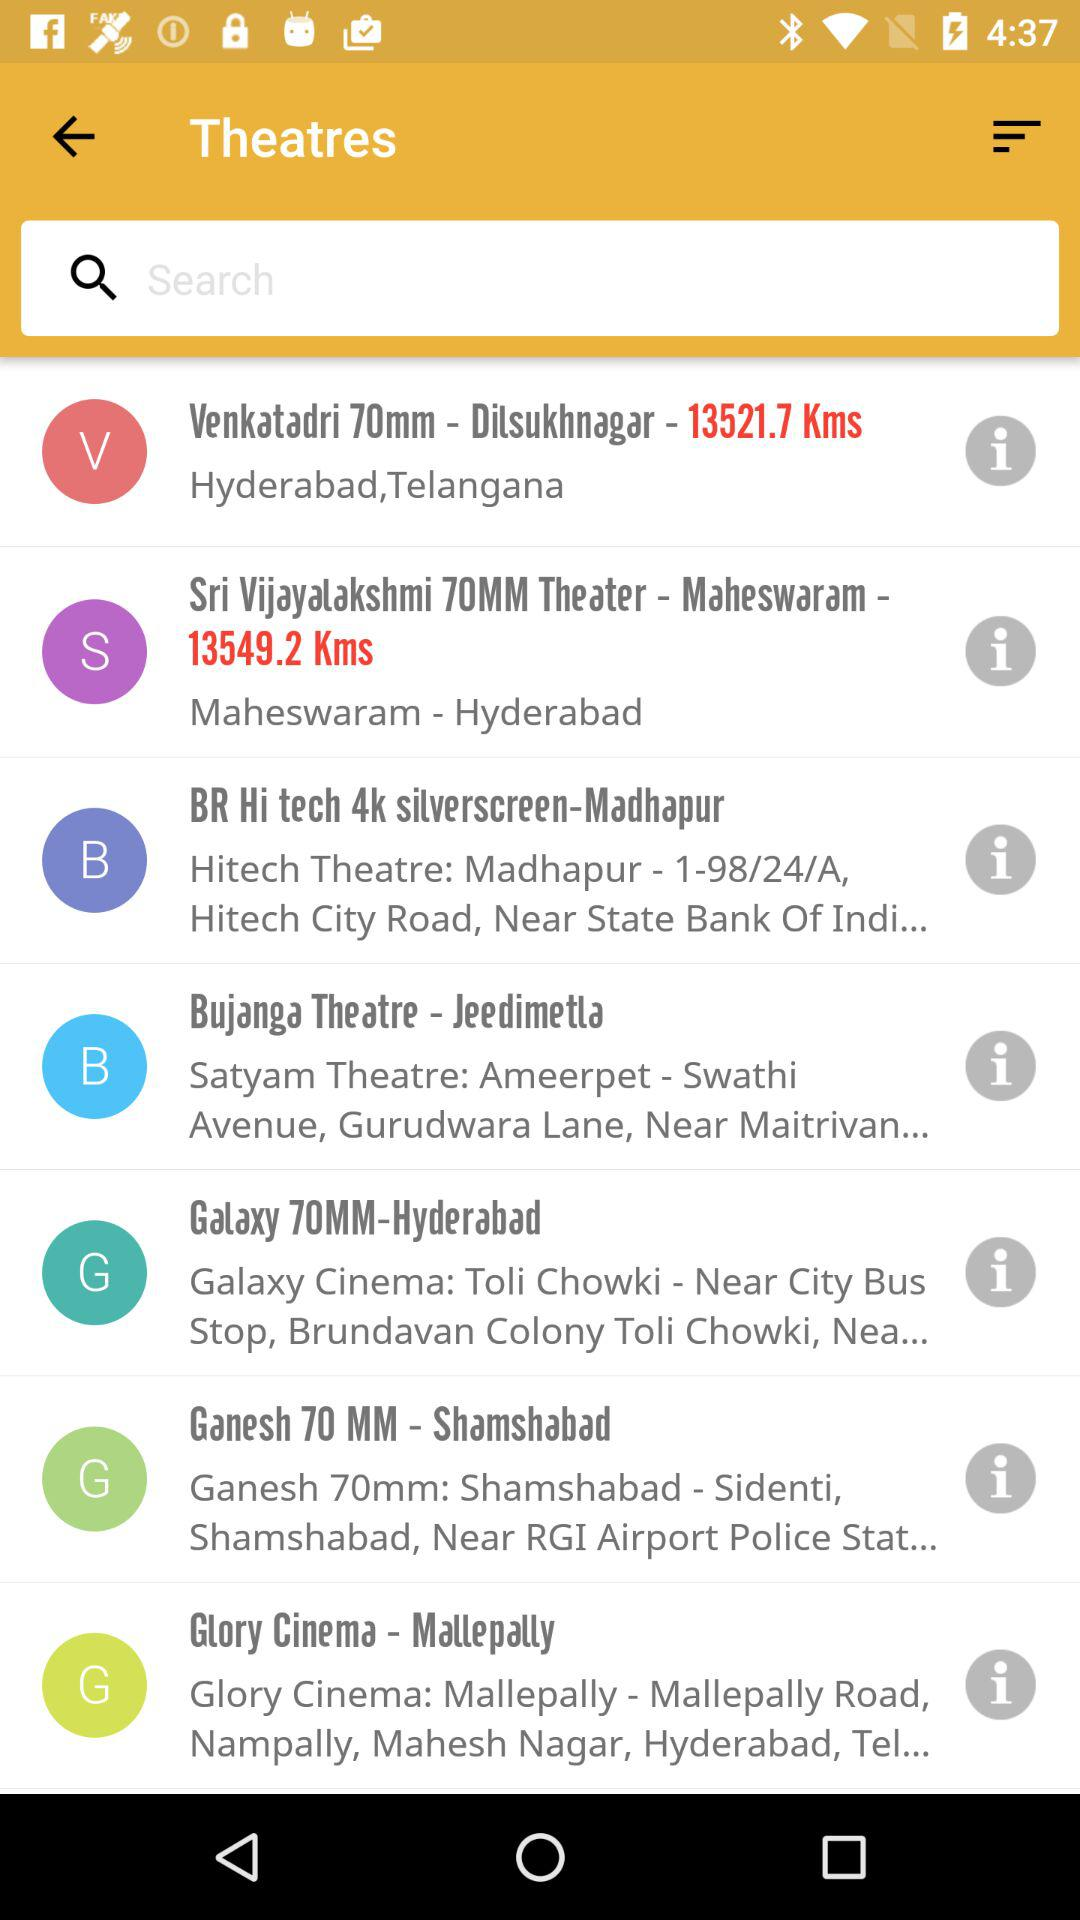What is the address of "Galaxy 70MM-Hyderabad"? The address of "Galaxy 70MM-Hyderabad" is "Galaxy Cinema: Toli Chowki - Near City Bus Stop, Brundavan Colony Toli Chowki, Nea...". 